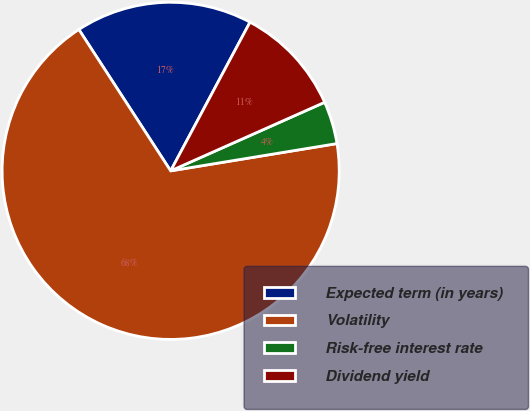Convert chart. <chart><loc_0><loc_0><loc_500><loc_500><pie_chart><fcel>Expected term (in years)<fcel>Volatility<fcel>Risk-free interest rate<fcel>Dividend yield<nl><fcel>16.97%<fcel>68.42%<fcel>4.08%<fcel>10.53%<nl></chart> 